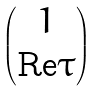<formula> <loc_0><loc_0><loc_500><loc_500>\begin{pmatrix} 1 \\ \text {Re} \tau \end{pmatrix}</formula> 